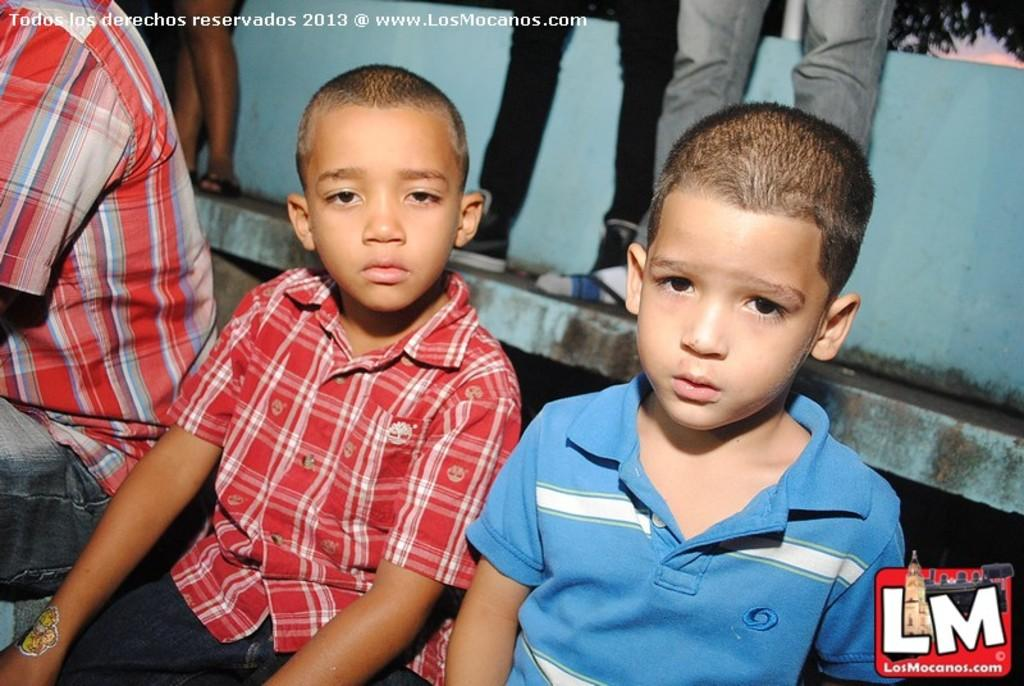How many kids are in the foreground of the picture? There are two kids in the foreground of the picture. Where is the person located in the picture? The person is on the left side of the picture. What can be seen in the background of the picture? There are people, a wall, and trees in the background of the picture. What is present at the bottom right corner of the picture? There is a logo at the bottom right corner of the picture. What type of haircut does the baseball have in the image? There is no baseball present in the image, so it is not possible to determine the type of haircut it might have. 